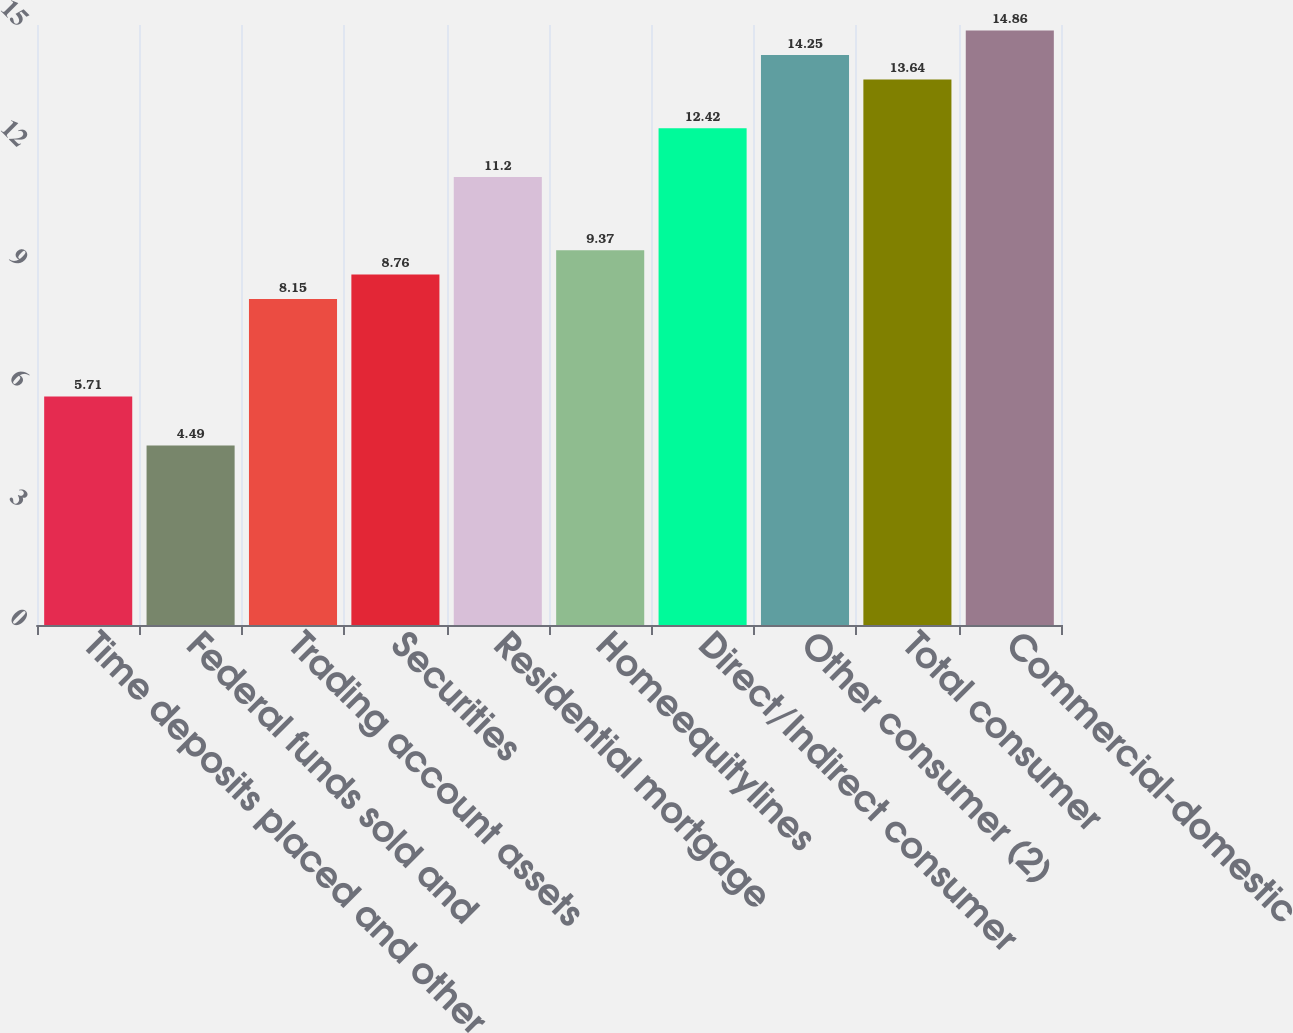Convert chart to OTSL. <chart><loc_0><loc_0><loc_500><loc_500><bar_chart><fcel>Time deposits placed and other<fcel>Federal funds sold and<fcel>Trading account assets<fcel>Securities<fcel>Residential mortgage<fcel>Homeequitylines<fcel>Direct/Indirect consumer<fcel>Other consumer (2)<fcel>Total consumer<fcel>Commercial-domestic<nl><fcel>5.71<fcel>4.49<fcel>8.15<fcel>8.76<fcel>11.2<fcel>9.37<fcel>12.42<fcel>14.25<fcel>13.64<fcel>14.86<nl></chart> 